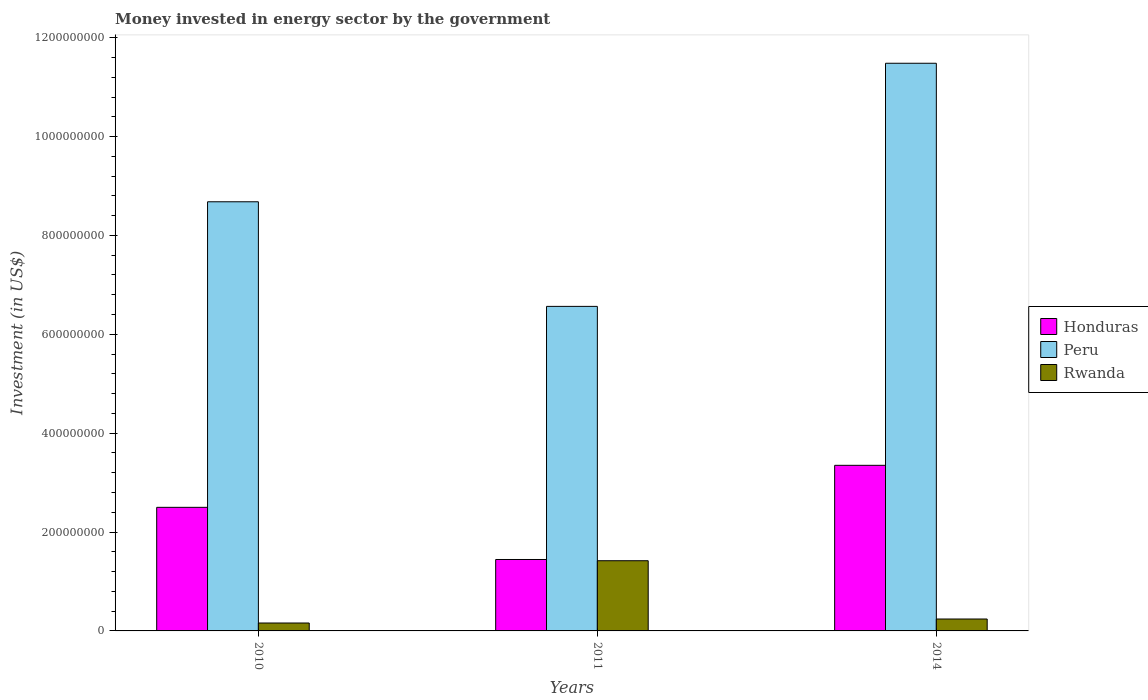How many different coloured bars are there?
Your response must be concise. 3. How many bars are there on the 1st tick from the left?
Give a very brief answer. 3. What is the money spent in energy sector in Peru in 2014?
Your answer should be very brief. 1.15e+09. Across all years, what is the maximum money spent in energy sector in Peru?
Offer a very short reply. 1.15e+09. Across all years, what is the minimum money spent in energy sector in Peru?
Your answer should be very brief. 6.56e+08. In which year was the money spent in energy sector in Peru maximum?
Make the answer very short. 2014. What is the total money spent in energy sector in Peru in the graph?
Make the answer very short. 2.67e+09. What is the difference between the money spent in energy sector in Honduras in 2010 and that in 2011?
Offer a terse response. 1.06e+08. What is the difference between the money spent in energy sector in Peru in 2011 and the money spent in energy sector in Honduras in 2014?
Your answer should be very brief. 3.22e+08. What is the average money spent in energy sector in Honduras per year?
Provide a short and direct response. 2.43e+08. In the year 2010, what is the difference between the money spent in energy sector in Honduras and money spent in energy sector in Peru?
Your answer should be compact. -6.18e+08. What is the ratio of the money spent in energy sector in Honduras in 2011 to that in 2014?
Give a very brief answer. 0.43. Is the money spent in energy sector in Honduras in 2010 less than that in 2011?
Provide a succinct answer. No. Is the difference between the money spent in energy sector in Honduras in 2011 and 2014 greater than the difference between the money spent in energy sector in Peru in 2011 and 2014?
Provide a succinct answer. Yes. What is the difference between the highest and the second highest money spent in energy sector in Peru?
Provide a succinct answer. 2.80e+08. What is the difference between the highest and the lowest money spent in energy sector in Honduras?
Your answer should be very brief. 1.90e+08. In how many years, is the money spent in energy sector in Peru greater than the average money spent in energy sector in Peru taken over all years?
Give a very brief answer. 1. What does the 1st bar from the left in 2010 represents?
Your answer should be very brief. Honduras. What does the 2nd bar from the right in 2011 represents?
Your answer should be very brief. Peru. Is it the case that in every year, the sum of the money spent in energy sector in Rwanda and money spent in energy sector in Peru is greater than the money spent in energy sector in Honduras?
Ensure brevity in your answer.  Yes. How many bars are there?
Your response must be concise. 9. Are all the bars in the graph horizontal?
Ensure brevity in your answer.  No. What is the difference between two consecutive major ticks on the Y-axis?
Provide a succinct answer. 2.00e+08. Are the values on the major ticks of Y-axis written in scientific E-notation?
Offer a terse response. No. How many legend labels are there?
Offer a very short reply. 3. How are the legend labels stacked?
Offer a very short reply. Vertical. What is the title of the graph?
Your response must be concise. Money invested in energy sector by the government. What is the label or title of the X-axis?
Your response must be concise. Years. What is the label or title of the Y-axis?
Your answer should be very brief. Investment (in US$). What is the Investment (in US$) of Honduras in 2010?
Your response must be concise. 2.50e+08. What is the Investment (in US$) of Peru in 2010?
Offer a terse response. 8.68e+08. What is the Investment (in US$) of Rwanda in 2010?
Make the answer very short. 1.60e+07. What is the Investment (in US$) of Honduras in 2011?
Give a very brief answer. 1.44e+08. What is the Investment (in US$) in Peru in 2011?
Your answer should be compact. 6.56e+08. What is the Investment (in US$) of Rwanda in 2011?
Make the answer very short. 1.42e+08. What is the Investment (in US$) of Honduras in 2014?
Your answer should be compact. 3.35e+08. What is the Investment (in US$) in Peru in 2014?
Give a very brief answer. 1.15e+09. What is the Investment (in US$) in Rwanda in 2014?
Keep it short and to the point. 2.41e+07. Across all years, what is the maximum Investment (in US$) of Honduras?
Make the answer very short. 3.35e+08. Across all years, what is the maximum Investment (in US$) in Peru?
Provide a succinct answer. 1.15e+09. Across all years, what is the maximum Investment (in US$) of Rwanda?
Provide a succinct answer. 1.42e+08. Across all years, what is the minimum Investment (in US$) of Honduras?
Offer a very short reply. 1.44e+08. Across all years, what is the minimum Investment (in US$) of Peru?
Your answer should be compact. 6.56e+08. Across all years, what is the minimum Investment (in US$) in Rwanda?
Provide a succinct answer. 1.60e+07. What is the total Investment (in US$) in Honduras in the graph?
Your response must be concise. 7.30e+08. What is the total Investment (in US$) of Peru in the graph?
Offer a terse response. 2.67e+09. What is the total Investment (in US$) in Rwanda in the graph?
Your answer should be very brief. 1.82e+08. What is the difference between the Investment (in US$) of Honduras in 2010 and that in 2011?
Offer a terse response. 1.06e+08. What is the difference between the Investment (in US$) of Peru in 2010 and that in 2011?
Your answer should be very brief. 2.12e+08. What is the difference between the Investment (in US$) of Rwanda in 2010 and that in 2011?
Your response must be concise. -1.26e+08. What is the difference between the Investment (in US$) of Honduras in 2010 and that in 2014?
Your answer should be very brief. -8.50e+07. What is the difference between the Investment (in US$) in Peru in 2010 and that in 2014?
Offer a terse response. -2.80e+08. What is the difference between the Investment (in US$) in Rwanda in 2010 and that in 2014?
Give a very brief answer. -8.10e+06. What is the difference between the Investment (in US$) of Honduras in 2011 and that in 2014?
Keep it short and to the point. -1.90e+08. What is the difference between the Investment (in US$) of Peru in 2011 and that in 2014?
Keep it short and to the point. -4.92e+08. What is the difference between the Investment (in US$) of Rwanda in 2011 and that in 2014?
Give a very brief answer. 1.18e+08. What is the difference between the Investment (in US$) in Honduras in 2010 and the Investment (in US$) in Peru in 2011?
Your response must be concise. -4.06e+08. What is the difference between the Investment (in US$) of Honduras in 2010 and the Investment (in US$) of Rwanda in 2011?
Offer a very short reply. 1.08e+08. What is the difference between the Investment (in US$) of Peru in 2010 and the Investment (in US$) of Rwanda in 2011?
Offer a very short reply. 7.26e+08. What is the difference between the Investment (in US$) in Honduras in 2010 and the Investment (in US$) in Peru in 2014?
Give a very brief answer. -8.98e+08. What is the difference between the Investment (in US$) of Honduras in 2010 and the Investment (in US$) of Rwanda in 2014?
Provide a short and direct response. 2.26e+08. What is the difference between the Investment (in US$) of Peru in 2010 and the Investment (in US$) of Rwanda in 2014?
Provide a succinct answer. 8.44e+08. What is the difference between the Investment (in US$) in Honduras in 2011 and the Investment (in US$) in Peru in 2014?
Give a very brief answer. -1.00e+09. What is the difference between the Investment (in US$) of Honduras in 2011 and the Investment (in US$) of Rwanda in 2014?
Your answer should be compact. 1.20e+08. What is the difference between the Investment (in US$) of Peru in 2011 and the Investment (in US$) of Rwanda in 2014?
Your response must be concise. 6.32e+08. What is the average Investment (in US$) in Honduras per year?
Your answer should be compact. 2.43e+08. What is the average Investment (in US$) of Peru per year?
Give a very brief answer. 8.91e+08. What is the average Investment (in US$) in Rwanda per year?
Provide a short and direct response. 6.07e+07. In the year 2010, what is the difference between the Investment (in US$) in Honduras and Investment (in US$) in Peru?
Your answer should be very brief. -6.18e+08. In the year 2010, what is the difference between the Investment (in US$) in Honduras and Investment (in US$) in Rwanda?
Give a very brief answer. 2.34e+08. In the year 2010, what is the difference between the Investment (in US$) in Peru and Investment (in US$) in Rwanda?
Your answer should be very brief. 8.52e+08. In the year 2011, what is the difference between the Investment (in US$) in Honduras and Investment (in US$) in Peru?
Make the answer very short. -5.12e+08. In the year 2011, what is the difference between the Investment (in US$) in Honduras and Investment (in US$) in Rwanda?
Your answer should be very brief. 2.50e+06. In the year 2011, what is the difference between the Investment (in US$) in Peru and Investment (in US$) in Rwanda?
Provide a short and direct response. 5.14e+08. In the year 2014, what is the difference between the Investment (in US$) of Honduras and Investment (in US$) of Peru?
Ensure brevity in your answer.  -8.13e+08. In the year 2014, what is the difference between the Investment (in US$) in Honduras and Investment (in US$) in Rwanda?
Make the answer very short. 3.11e+08. In the year 2014, what is the difference between the Investment (in US$) in Peru and Investment (in US$) in Rwanda?
Your answer should be very brief. 1.12e+09. What is the ratio of the Investment (in US$) in Honduras in 2010 to that in 2011?
Make the answer very short. 1.73. What is the ratio of the Investment (in US$) of Peru in 2010 to that in 2011?
Your answer should be compact. 1.32. What is the ratio of the Investment (in US$) of Rwanda in 2010 to that in 2011?
Make the answer very short. 0.11. What is the ratio of the Investment (in US$) in Honduras in 2010 to that in 2014?
Ensure brevity in your answer.  0.75. What is the ratio of the Investment (in US$) in Peru in 2010 to that in 2014?
Keep it short and to the point. 0.76. What is the ratio of the Investment (in US$) in Rwanda in 2010 to that in 2014?
Offer a very short reply. 0.66. What is the ratio of the Investment (in US$) of Honduras in 2011 to that in 2014?
Ensure brevity in your answer.  0.43. What is the ratio of the Investment (in US$) of Peru in 2011 to that in 2014?
Keep it short and to the point. 0.57. What is the ratio of the Investment (in US$) in Rwanda in 2011 to that in 2014?
Your response must be concise. 5.89. What is the difference between the highest and the second highest Investment (in US$) of Honduras?
Your response must be concise. 8.50e+07. What is the difference between the highest and the second highest Investment (in US$) of Peru?
Provide a short and direct response. 2.80e+08. What is the difference between the highest and the second highest Investment (in US$) of Rwanda?
Keep it short and to the point. 1.18e+08. What is the difference between the highest and the lowest Investment (in US$) in Honduras?
Your response must be concise. 1.90e+08. What is the difference between the highest and the lowest Investment (in US$) of Peru?
Offer a terse response. 4.92e+08. What is the difference between the highest and the lowest Investment (in US$) in Rwanda?
Your response must be concise. 1.26e+08. 